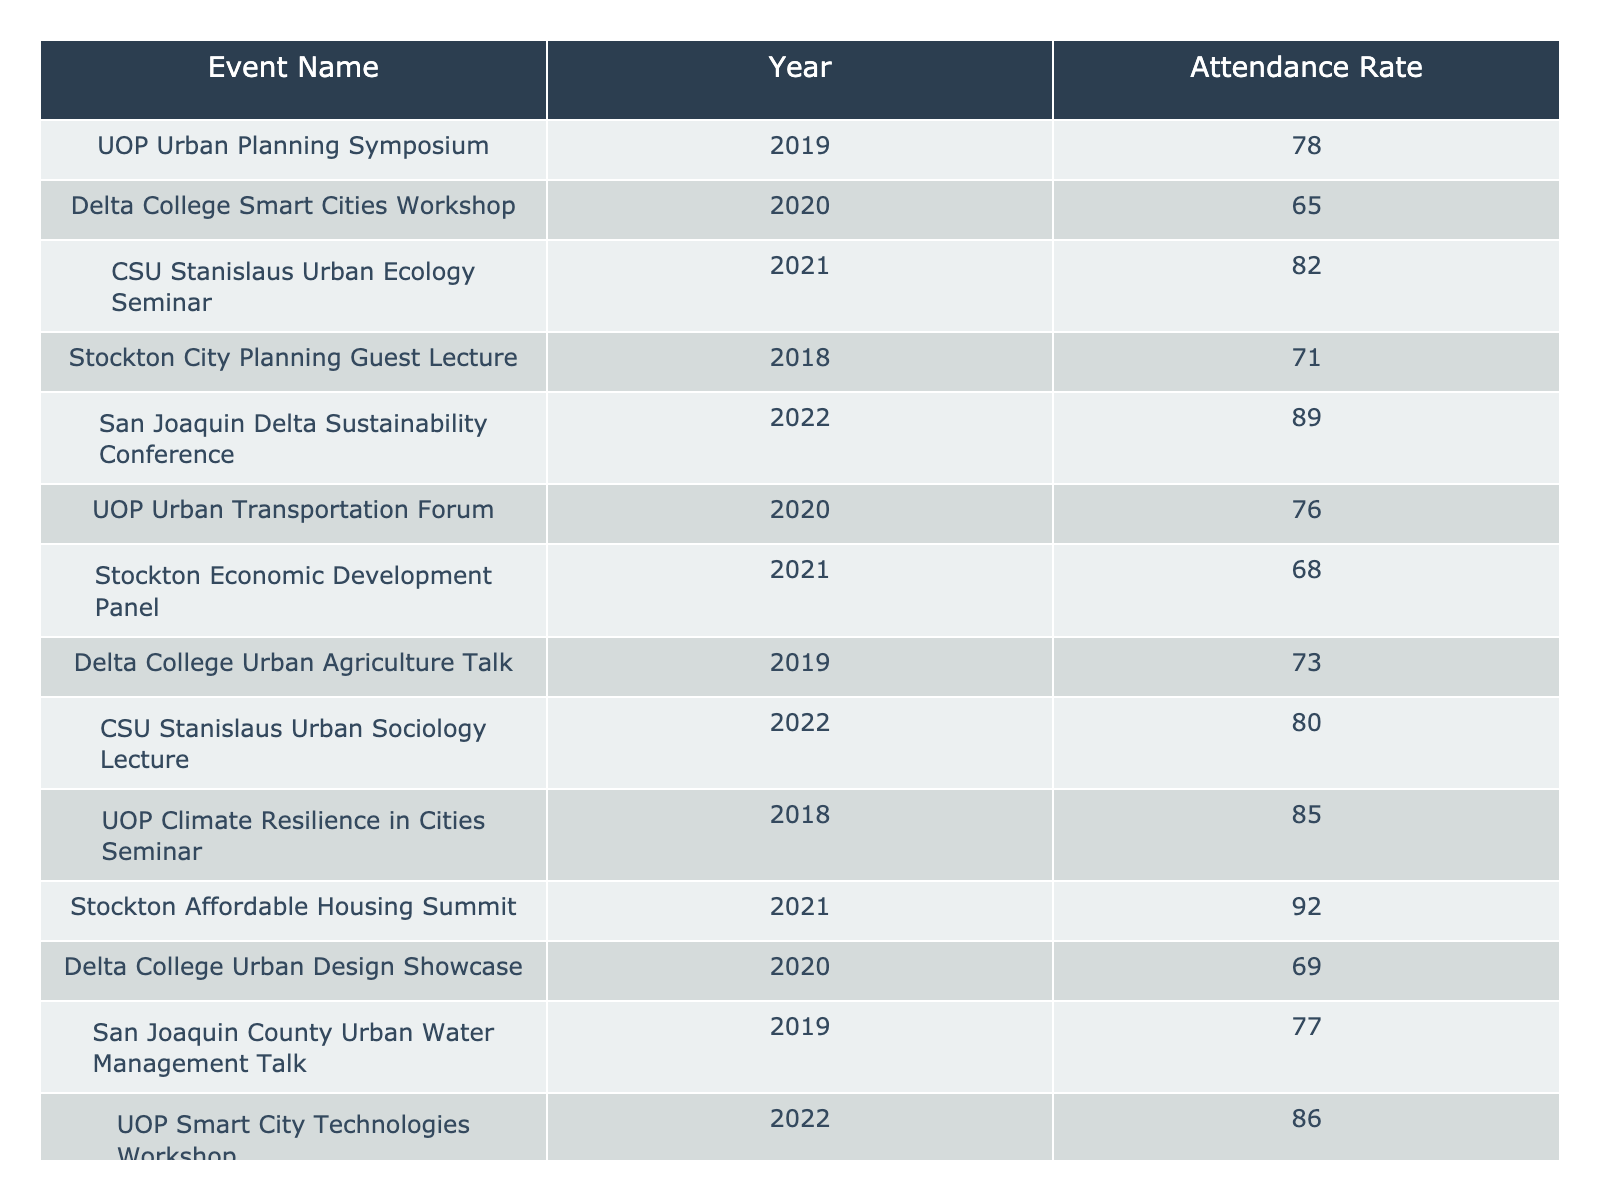What was the highest attendance rate for an event in 2022? The table lists the attendance rates for events in 2022, where the "San Joaquin Delta Sustainability Conference" has an attendance rate of 89, and "CSU Stanislaus Urban Sociology Lecture" has an attendance rate of 80. The highest among these is 89.
Answer: 89 Which event had the lowest attendance rate, and what was that rate? By reviewing the attendance rates, "Delta College Urban Design Showcase" in 2020 has the lowest rate recorded at 69.
Answer: 69 What is the average attendance rate for events in 2019? The events in 2019 are: "Delta College Urban Agriculture Talk" (73), "San Joaquin County Urban Water Management Talk" (77), and "UOP Urban Planning Symposium" (78). Their sum is 73 + 77 + 78 = 228, and the average is 228/3 = 76.
Answer: 76 Did the attendance rate for the "Stockton Affordable Housing Summit" exceed 90? The table shows that the "Stockton Affordable Housing Summit" had an attendance rate of 92, which is greater than 90.
Answer: Yes How does the average attendance rate for 2020 compare to that of 2021? For 2020, the events are: "Delta College Smart Cities Workshop" (65), "UOP Urban Transportation Forum" (76), and "Delta College Urban Design Showcase" (69). Their sum is 65 + 76 + 69 = 210, with an average of 210/3 = 70. For 2021, the events are: "CSU Stanislaus Urban Ecology Seminar" (82), "Stockton Economic Development Panel" (68), and "Stockton Affordable Housing Summit" (92), summing to 82 + 68 + 92 = 242 and an average of 242/3 = 80.67. Comparing these averages, 80.67 is higher than 70.
Answer: 80.67 is higher than 70 What percentage of events listed had an attendance rate of 80 or higher? There are 15 events total. Of these, 7 have an attendance rate of 80 or higher: "CSU Stanislaus Urban Ecology Seminar" (82), "San Joaquin Delta Sustainability Conference" (89), "UOP Smart City Technologies Workshop" (86), "Stockton Affordable Housing Summit" (92), "UOP Climate Resilience in Cities Seminar" (85), "CSU Stanislaus Urban Sociology Lecture" (80), and "UOP Urban Transportation Forum" (76) does not count. To find the percentage, (7/15) * 100 = 46.67%.
Answer: Approximately 46.67% 